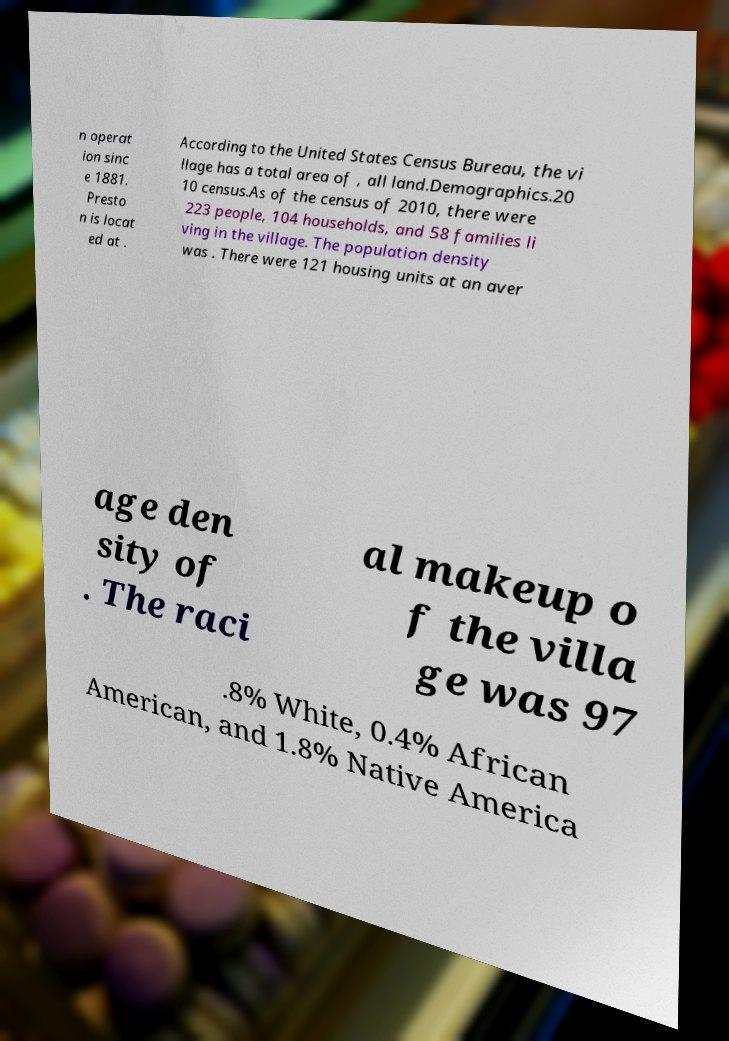Please identify and transcribe the text found in this image. n operat ion sinc e 1881. Presto n is locat ed at . According to the United States Census Bureau, the vi llage has a total area of , all land.Demographics.20 10 census.As of the census of 2010, there were 223 people, 104 households, and 58 families li ving in the village. The population density was . There were 121 housing units at an aver age den sity of . The raci al makeup o f the villa ge was 97 .8% White, 0.4% African American, and 1.8% Native America 